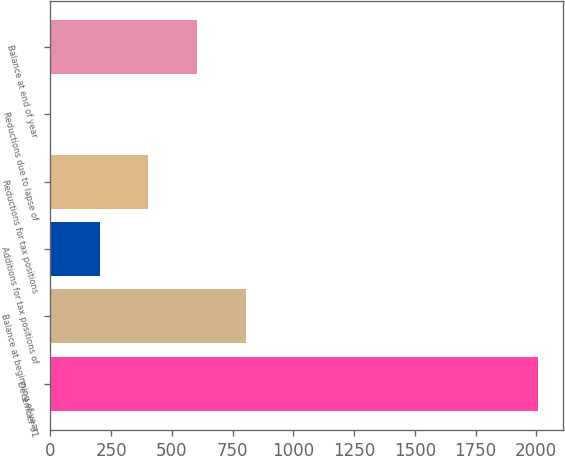Convert chart to OTSL. <chart><loc_0><loc_0><loc_500><loc_500><bar_chart><fcel>December 31<fcel>Balance at beginning of year<fcel>Additions for tax positions of<fcel>Reductions for tax positions<fcel>Reductions due to lapse of<fcel>Balance at end of year<nl><fcel>2009<fcel>804.8<fcel>202.7<fcel>403.4<fcel>2<fcel>604.1<nl></chart> 